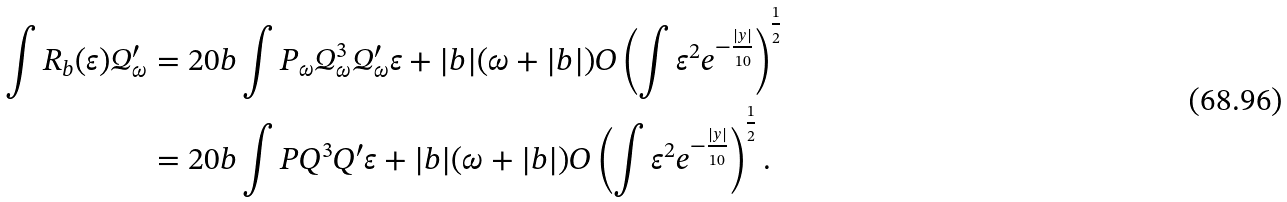<formula> <loc_0><loc_0><loc_500><loc_500>\int R _ { b } ( \varepsilon ) \mathcal { Q } _ { \omega } ^ { \prime } & = 2 0 b \int P _ { \omega } \mathcal { Q } _ { \omega } ^ { 3 } \mathcal { Q } _ { \omega } ^ { \prime } \varepsilon + | b | ( \omega + | b | ) O \left ( \int \varepsilon ^ { 2 } e ^ { - \frac { | y | } { 1 0 } } \right ) ^ { \frac { 1 } { 2 } } \\ & = 2 0 b \int P Q ^ { 3 } Q ^ { \prime } \varepsilon + | b | ( \omega + | b | ) O \left ( \int \varepsilon ^ { 2 } e ^ { - \frac { | y | } { 1 0 } } \right ) ^ { \frac { 1 } { 2 } } .</formula> 